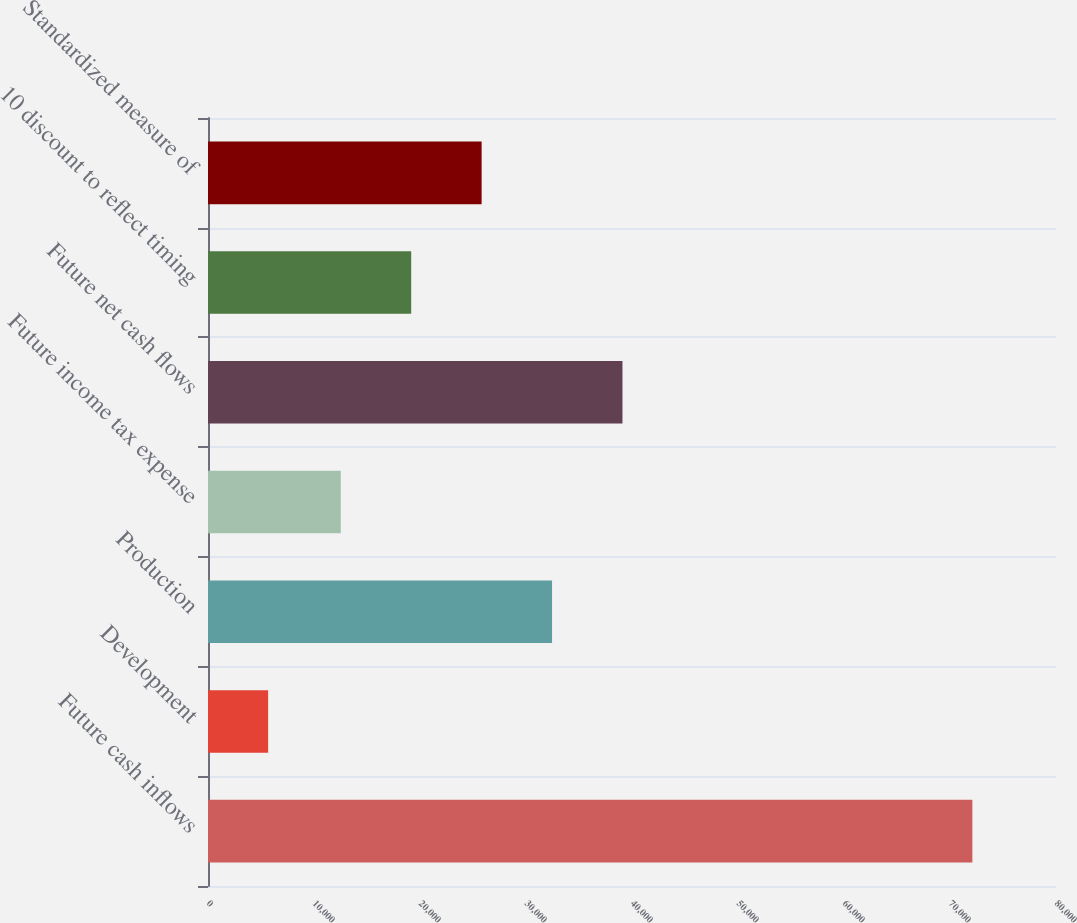Convert chart to OTSL. <chart><loc_0><loc_0><loc_500><loc_500><bar_chart><fcel>Future cash inflows<fcel>Development<fcel>Production<fcel>Future income tax expense<fcel>Future net cash flows<fcel>10 discount to reflect timing<fcel>Standardized measure of<nl><fcel>72109<fcel>5673<fcel>32456.8<fcel>12526<fcel>39100.4<fcel>19169.6<fcel>25813.2<nl></chart> 